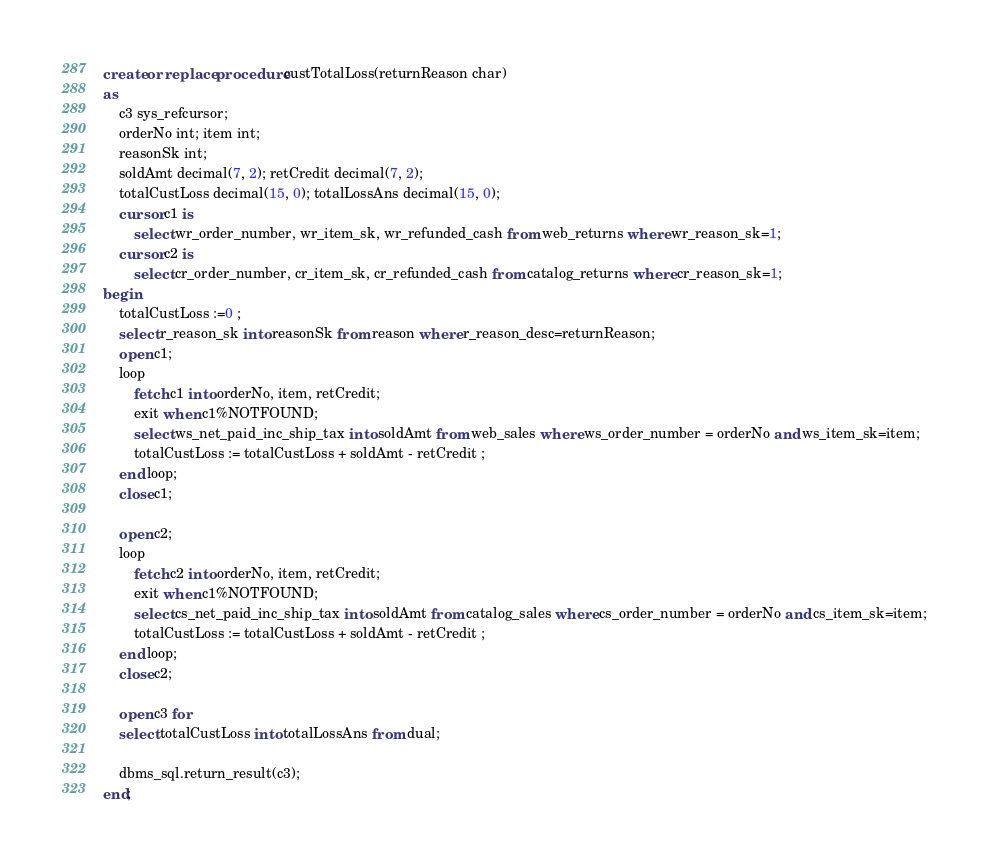Convert code to text. <code><loc_0><loc_0><loc_500><loc_500><_SQL_>create or replace procedure custTotalLoss(returnReason char)
as 
    c3 sys_refcursor; 
	orderNo int; item int;
	reasonSk int;
	soldAmt decimal(7, 2); retCredit decimal(7, 2);
	totalCustLoss decimal(15, 0); totalLossAns decimal(15, 0);
    cursor c1 is 
        select wr_order_number, wr_item_sk, wr_refunded_cash from web_returns where wr_reason_sk=1;
    cursor c2 is 
        select cr_order_number, cr_item_sk, cr_refunded_cash from catalog_returns where cr_reason_sk=1;
begin	
	totalCustLoss :=0 ;
	select r_reason_sk into reasonSk from reason where r_reason_desc=returnReason;
	open c1;
    loop
        fetch c1 into orderNo, item, retCredit;
        exit when c1%NOTFOUND;
		select ws_net_paid_inc_ship_tax into soldAmt from web_sales where ws_order_number = orderNo and ws_item_sk=item;
		totalCustLoss := totalCustLoss + soldAmt - retCredit ;
	end loop;
	close c1;

	open c2;
    loop
        fetch c2 into orderNo, item, retCredit;
        exit when c1%NOTFOUND;
		select cs_net_paid_inc_ship_tax into soldAmt from catalog_sales where cs_order_number = orderNo and cs_item_sk=item;
		totalCustLoss := totalCustLoss + soldAmt - retCredit ;
	end loop;
    close c2;
    
    open c3 for 
	select totalCustLoss into totalLossAns from dual;
    
    dbms_sql.return_result(c3);
end;</code> 